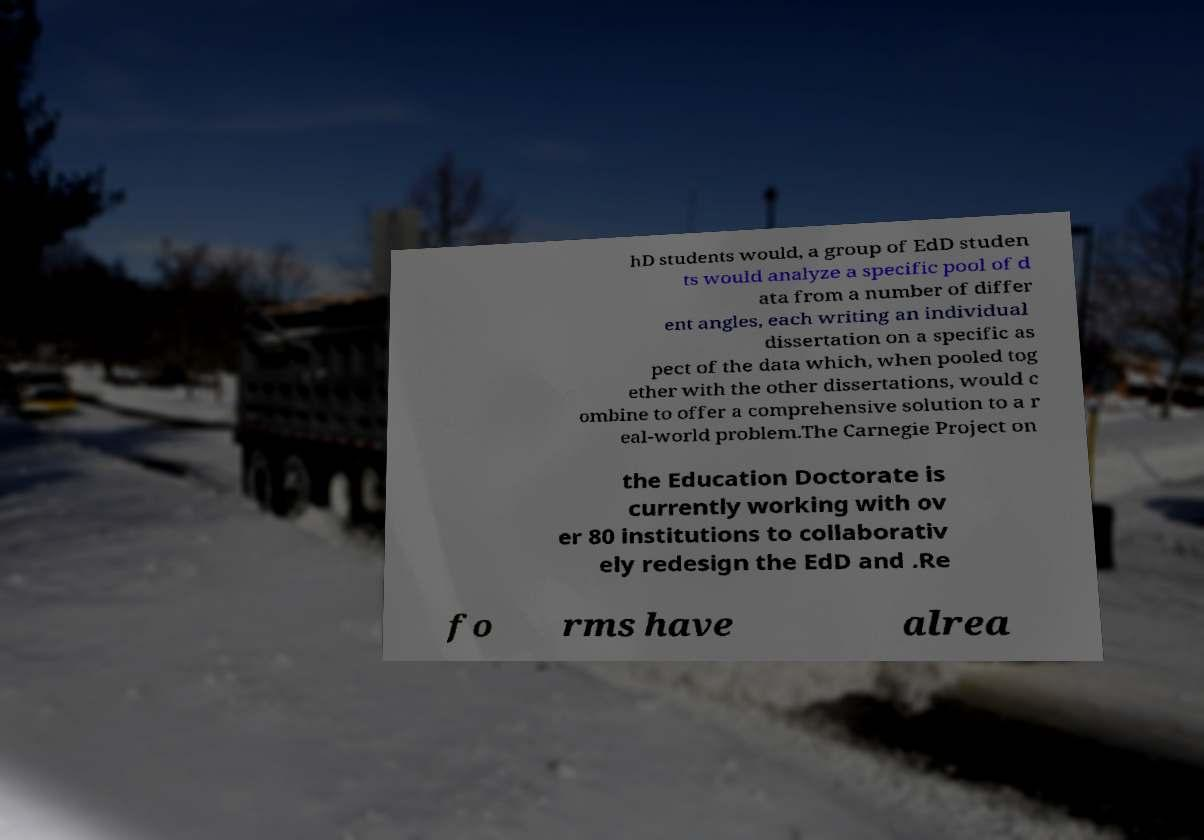There's text embedded in this image that I need extracted. Can you transcribe it verbatim? hD students would, a group of EdD studen ts would analyze a specific pool of d ata from a number of differ ent angles, each writing an individual dissertation on a specific as pect of the data which, when pooled tog ether with the other dissertations, would c ombine to offer a comprehensive solution to a r eal-world problem.The Carnegie Project on the Education Doctorate is currently working with ov er 80 institutions to collaborativ ely redesign the EdD and .Re fo rms have alrea 